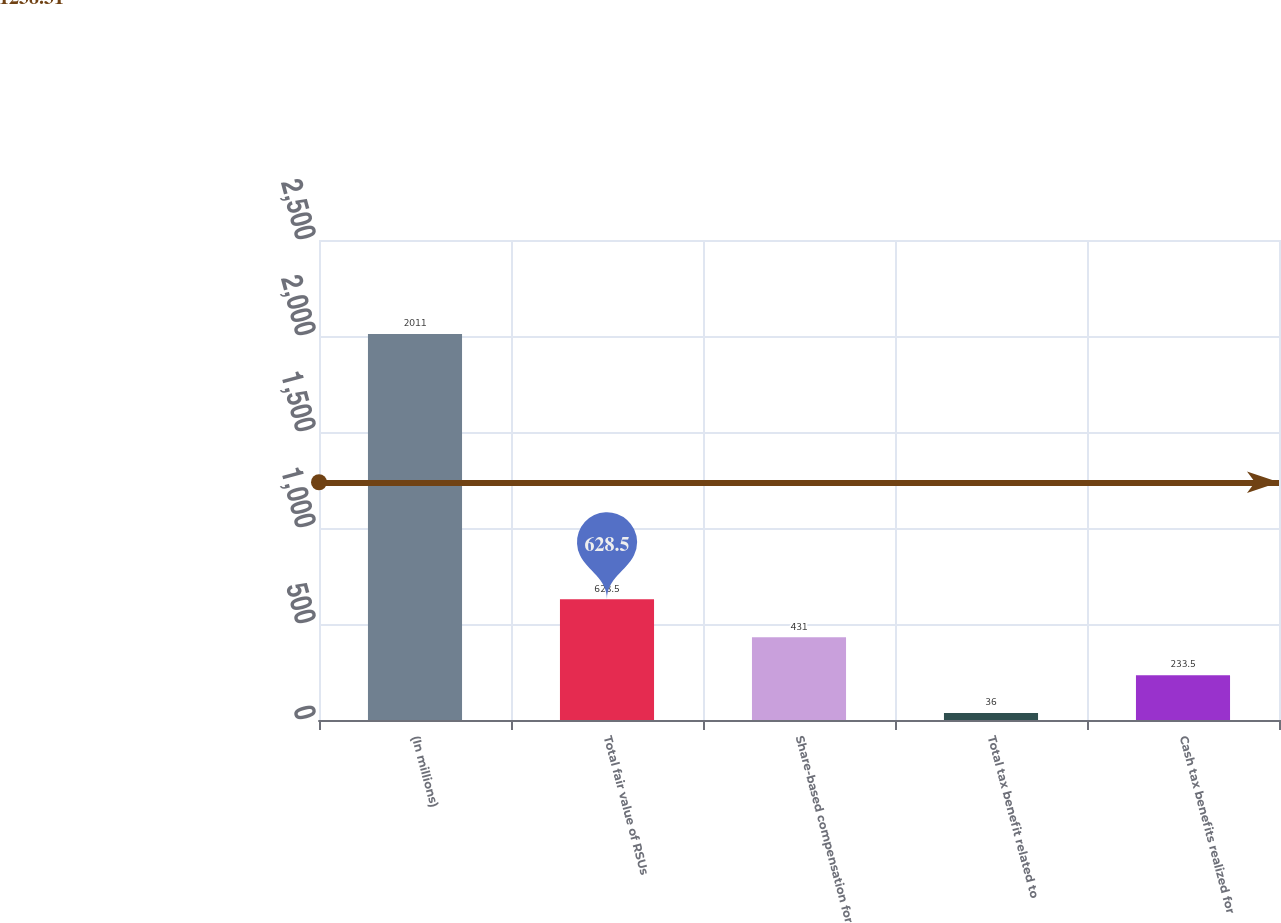<chart> <loc_0><loc_0><loc_500><loc_500><bar_chart><fcel>(In millions)<fcel>Total fair value of RSUs<fcel>Share-based compensation for<fcel>Total tax benefit related to<fcel>Cash tax benefits realized for<nl><fcel>2011<fcel>628.5<fcel>431<fcel>36<fcel>233.5<nl></chart> 